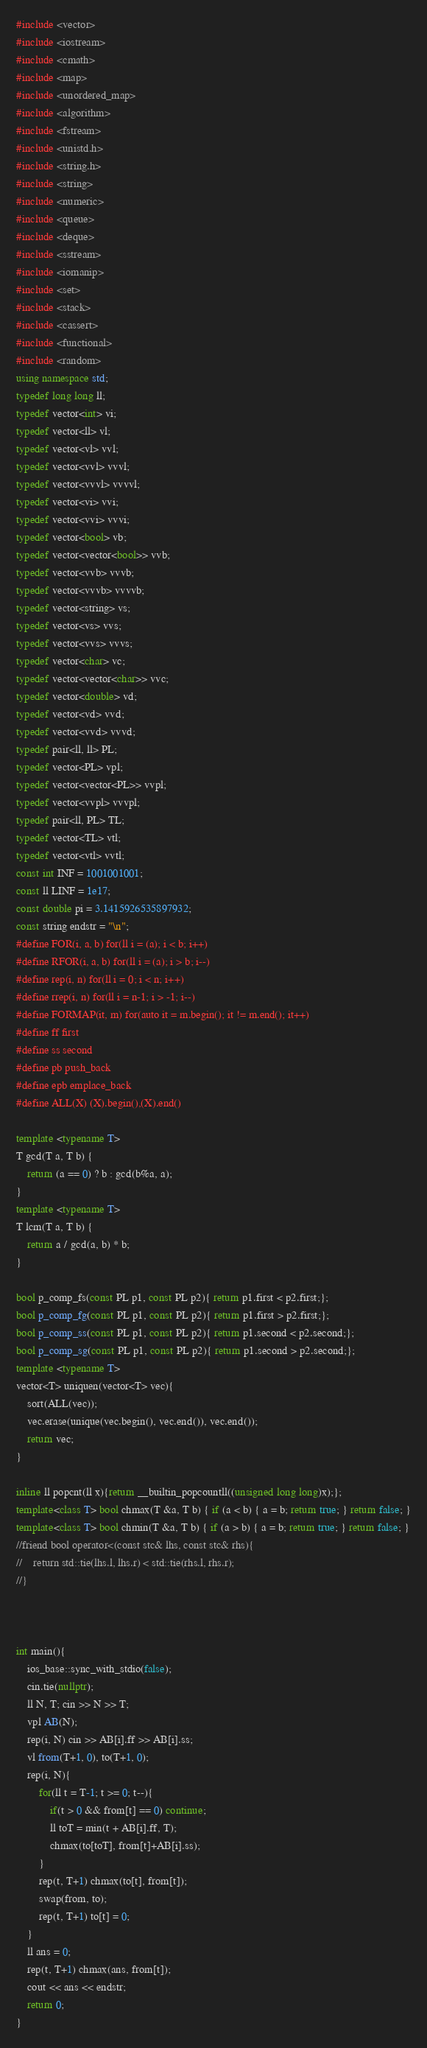<code> <loc_0><loc_0><loc_500><loc_500><_C++_>#include <vector>
#include <iostream>
#include <cmath>
#include <map>
#include <unordered_map>
#include <algorithm>
#include <fstream>
#include <unistd.h>
#include <string.h>
#include <string>
#include <numeric>
#include <queue>
#include <deque>
#include <sstream>
#include <iomanip>
#include <set>
#include <stack>
#include <cassert>
#include <functional>
#include <random>
using namespace std;
typedef long long ll;
typedef vector<int> vi;
typedef vector<ll> vl;
typedef vector<vl> vvl;
typedef vector<vvl> vvvl;
typedef vector<vvvl> vvvvl;
typedef vector<vi> vvi;
typedef vector<vvi> vvvi;
typedef vector<bool> vb;
typedef vector<vector<bool>> vvb;
typedef vector<vvb> vvvb;
typedef vector<vvvb> vvvvb;
typedef vector<string> vs;
typedef vector<vs> vvs;
typedef vector<vvs> vvvs;
typedef vector<char> vc;
typedef vector<vector<char>> vvc;
typedef vector<double> vd;
typedef vector<vd> vvd;
typedef vector<vvd> vvvd;
typedef pair<ll, ll> PL;
typedef vector<PL> vpl;
typedef vector<vector<PL>> vvpl;
typedef vector<vvpl> vvvpl;
typedef pair<ll, PL> TL;
typedef vector<TL> vtl;
typedef vector<vtl> vvtl;
const int INF = 1001001001;
const ll LINF = 1e17;
const double pi = 3.1415926535897932;
const string endstr = "\n";
#define FOR(i, a, b) for(ll i = (a); i < b; i++)
#define RFOR(i, a, b) for(ll i = (a); i > b; i--)
#define rep(i, n) for(ll i = 0; i < n; i++)
#define rrep(i, n) for(ll i = n-1; i > -1; i--)
#define FORMAP(it, m) for(auto it = m.begin(); it != m.end(); it++)
#define ff first
#define ss second
#define pb push_back
#define epb emplace_back
#define ALL(X) (X).begin(),(X).end()

template <typename T>
T gcd(T a, T b) {
    return (a == 0) ? b : gcd(b%a, a);
}
template <typename T>
T lcm(T a, T b) {
    return a / gcd(a, b) * b;
}

bool p_comp_fs(const PL p1, const PL p2){ return p1.first < p2.first;};
bool p_comp_fg(const PL p1, const PL p2){ return p1.first > p2.first;};
bool p_comp_ss(const PL p1, const PL p2){ return p1.second < p2.second;};
bool p_comp_sg(const PL p1, const PL p2){ return p1.second > p2.second;};
template <typename T>
vector<T> uniquen(vector<T> vec){
    sort(ALL(vec));
    vec.erase(unique(vec.begin(), vec.end()), vec.end());
    return vec;
}

inline ll popcnt(ll x){return __builtin_popcountll((unsigned long long)x);};
template<class T> bool chmax(T &a, T b) { if (a < b) { a = b; return true; } return false; }
template<class T> bool chmin(T &a, T b) { if (a > b) { a = b; return true; } return false; }
//friend bool operator<(const stc& lhs, const stc& rhs){
//    return std::tie(lhs.l, lhs.r) < std::tie(rhs.l, rhs.r);
//}



int main(){
    ios_base::sync_with_stdio(false);
    cin.tie(nullptr);
    ll N, T; cin >> N >> T;
    vpl AB(N);
    rep(i, N) cin >> AB[i].ff >> AB[i].ss;
    vl from(T+1, 0), to(T+1, 0);
    rep(i, N){
        for(ll t = T-1; t >= 0; t--){
            if(t > 0 && from[t] == 0) continue;
            ll toT = min(t + AB[i].ff, T);
            chmax(to[toT], from[t]+AB[i].ss);
        }
        rep(t, T+1) chmax(to[t], from[t]);
        swap(from, to);
        rep(t, T+1) to[t] = 0;
    }
    ll ans = 0;
    rep(t, T+1) chmax(ans, from[t]);
    cout << ans << endstr;
    return 0;
}
</code> 